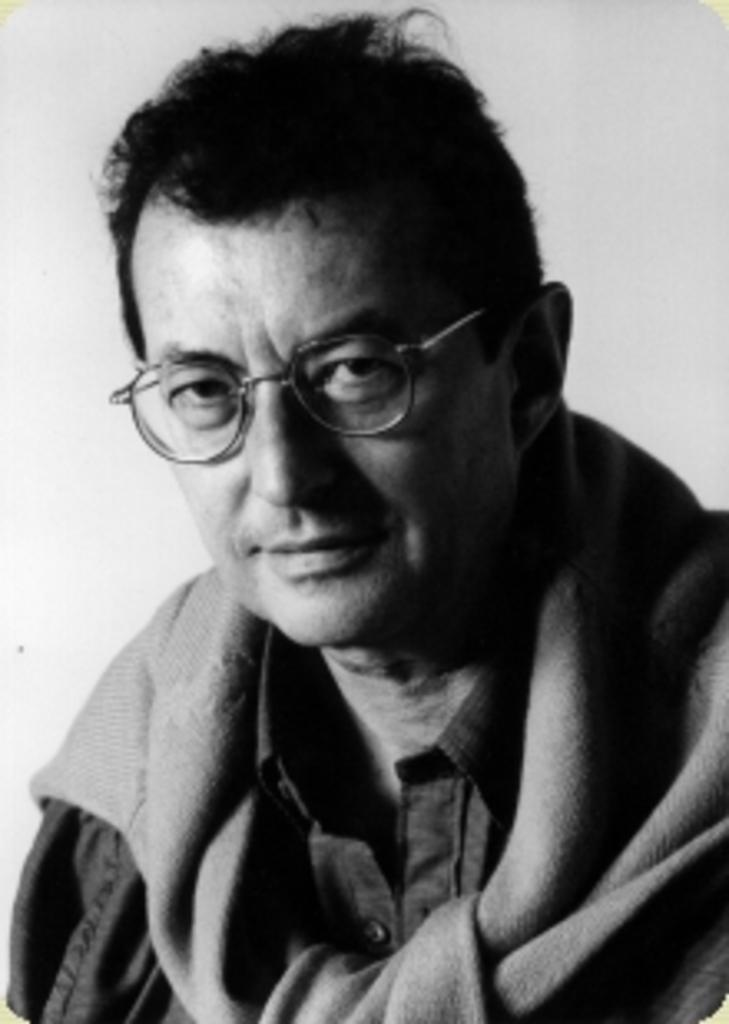What is the color scheme of the image? The image is black and white. Who is present in the image? There is a man in the image. What is the man wearing? The man is wearing clothes and spectacles. What is the background of the image? The background of the image is white. How many potatoes can be seen in the image? There are no potatoes present in the image. What type of girls are depicted in the image? There are no girls depicted in the image; it features a man. 